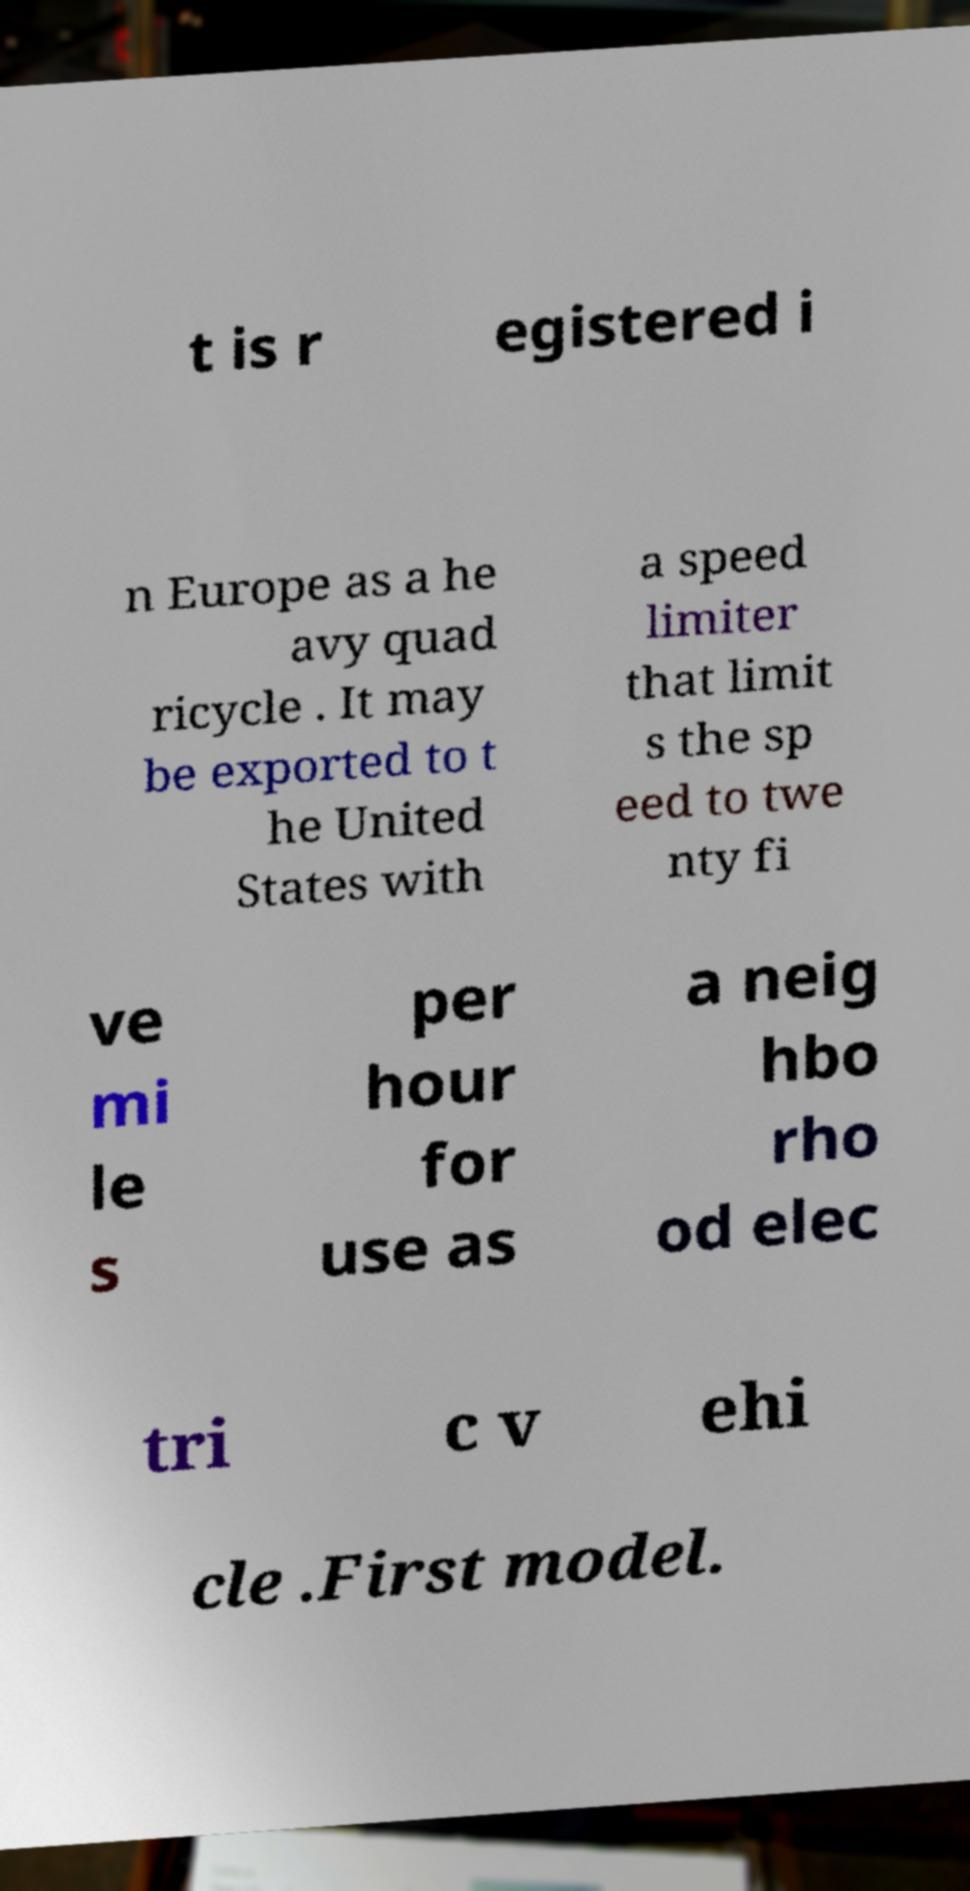There's text embedded in this image that I need extracted. Can you transcribe it verbatim? t is r egistered i n Europe as a he avy quad ricycle . It may be exported to t he United States with a speed limiter that limit s the sp eed to twe nty fi ve mi le s per hour for use as a neig hbo rho od elec tri c v ehi cle .First model. 